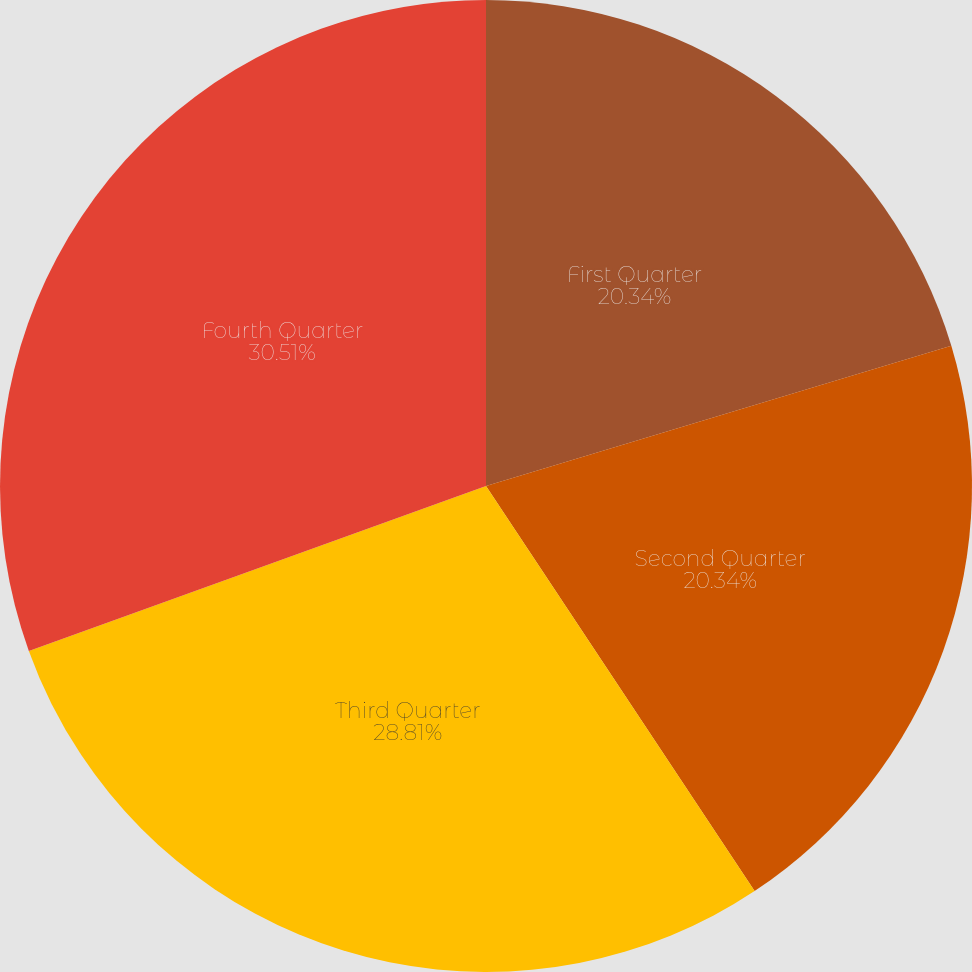Convert chart to OTSL. <chart><loc_0><loc_0><loc_500><loc_500><pie_chart><fcel>First Quarter<fcel>Second Quarter<fcel>Third Quarter<fcel>Fourth Quarter<nl><fcel>20.34%<fcel>20.34%<fcel>28.81%<fcel>30.51%<nl></chart> 